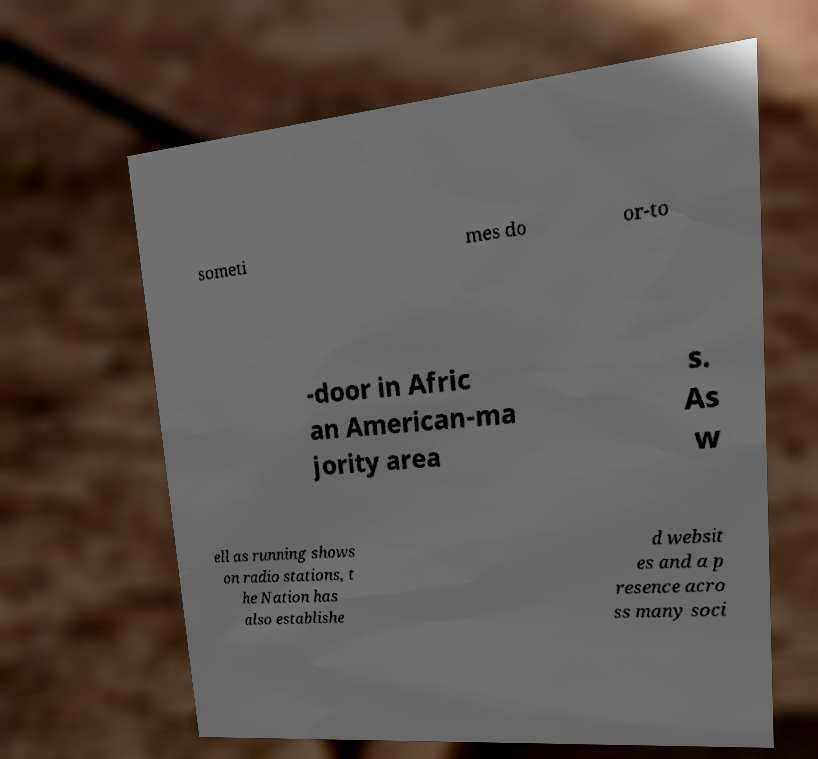Could you assist in decoding the text presented in this image and type it out clearly? someti mes do or-to -door in Afric an American-ma jority area s. As w ell as running shows on radio stations, t he Nation has also establishe d websit es and a p resence acro ss many soci 